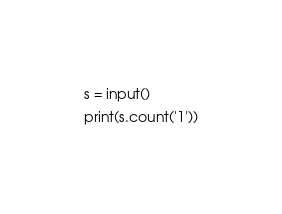Convert code to text. <code><loc_0><loc_0><loc_500><loc_500><_Python_>s = input()
print(s.count('1'))</code> 